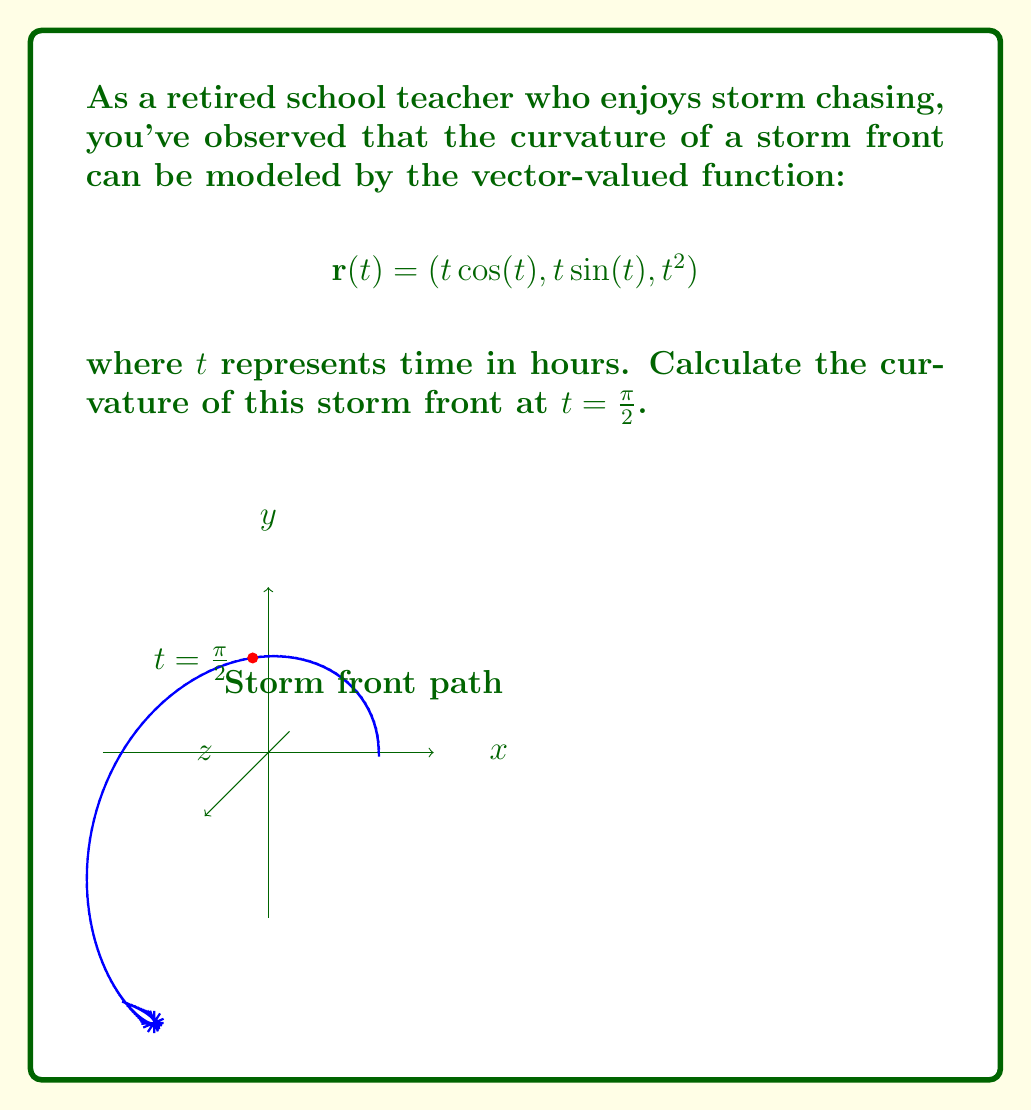Teach me how to tackle this problem. To calculate the curvature, we'll use the formula:

$$\kappa = \frac{|\mathbf{r}'(t) \times \mathbf{r}''(t)|}{|\mathbf{r}'(t)|^3}$$

Step 1: Calculate $\mathbf{r}'(t)$
$$\mathbf{r}'(t) = (\cos(t) - t\sin(t), \sin(t) + t\cos(t), 2t)$$

Step 2: Calculate $\mathbf{r}''(t)$
$$\mathbf{r}''(t) = (-2\sin(t) - t\cos(t), 2\cos(t) - t\sin(t), 2)$$

Step 3: Evaluate $\mathbf{r}'(\frac{\pi}{2})$ and $\mathbf{r}''(\frac{\pi}{2})$
$$\mathbf{r}'(\frac{\pi}{2}) = (-\frac{\pi}{2}, 1, \pi)$$
$$\mathbf{r}''(\frac{\pi}{2}) = (-1, -\frac{\pi}{2}, 2)$$

Step 4: Calculate $\mathbf{r}'(\frac{\pi}{2}) \times \mathbf{r}''(\frac{\pi}{2})$
$$\mathbf{r}'(\frac{\pi}{2}) \times \mathbf{r}''(\frac{\pi}{2}) = \begin{vmatrix} 
\mathbf{i} & \mathbf{j} & \mathbf{k} \\
-\frac{\pi}{2} & 1 & \pi \\
-1 & -\frac{\pi}{2} & 2
\end{vmatrix} = (-\frac{\pi^2}{2}-2)\mathbf{i} + (\frac{\pi^2}{2}+\pi)\mathbf{j} + (\frac{\pi^2}{4}-1)\mathbf{k}$$

Step 5: Calculate $|\mathbf{r}'(\frac{\pi}{2}) \times \mathbf{r}''(\frac{\pi}{2})|$
$$|\mathbf{r}'(\frac{\pi}{2}) \times \mathbf{r}''(\frac{\pi}{2})| = \sqrt{(-\frac{\pi^2}{2}-2)^2 + (\frac{\pi^2}{2}+\pi)^2 + (\frac{\pi^2}{4}-1)^2}$$

Step 6: Calculate $|\mathbf{r}'(\frac{\pi}{2})|^3$
$$|\mathbf{r}'(\frac{\pi}{2})|^3 = ((-\frac{\pi}{2})^2 + 1^2 + \pi^2)^{\frac{3}{2}} = (\frac{\pi^2}{4} + 1 + \pi^2)^{\frac{3}{2}} = (\frac{5\pi^2}{4} + 1)^{\frac{3}{2}}$$

Step 7: Calculate the curvature
$$\kappa = \frac{\sqrt{(-\frac{\pi^2}{2}-2)^2 + (\frac{\pi^2}{2}+\pi)^2 + (\frac{\pi^2}{4}-1)^2}}{(\frac{5\pi^2}{4} + 1)^{\frac{3}{2}}}$$
Answer: $$\kappa = \frac{\sqrt{(-\frac{\pi^2}{2}-2)^2 + (\frac{\pi^2}{2}+\pi)^2 + (\frac{\pi^2}{4}-1)^2}}{(\frac{5\pi^2}{4} + 1)^{\frac{3}{2}}}$$ 